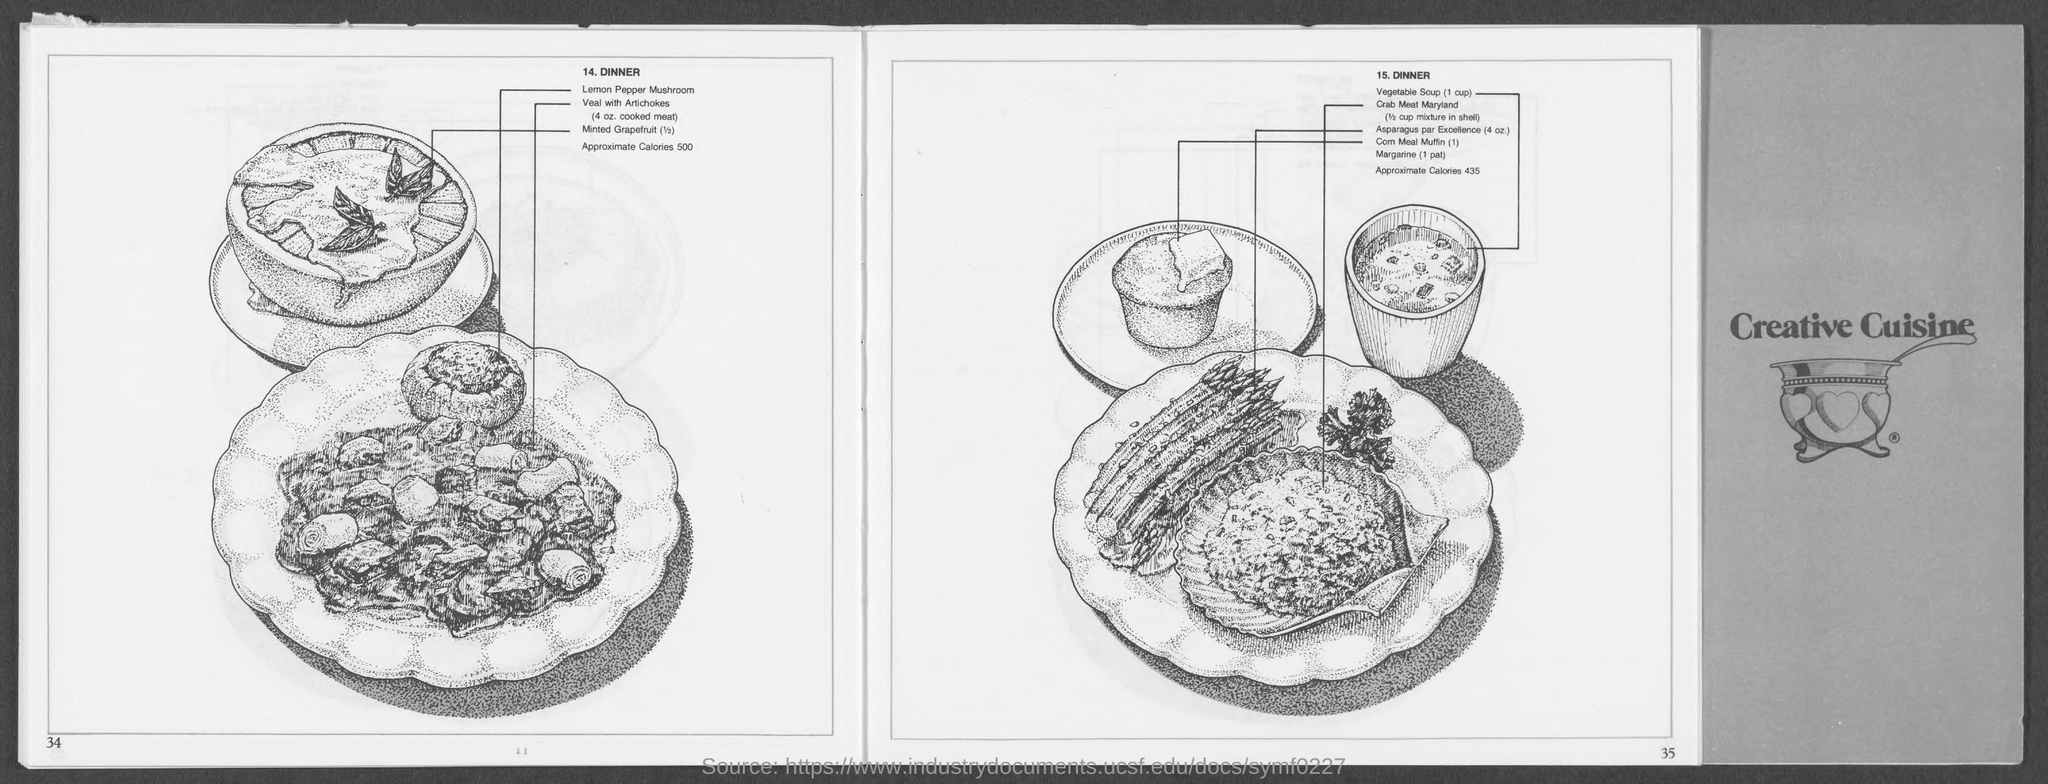Draw attention to some important aspects in this diagram. In the recipe, it is mentioned that 4 ounces of cooked veal is used, along with artichokes. The book cover features the name "Creative Cuisine" prominently displayed. 